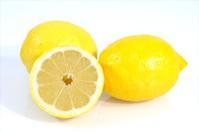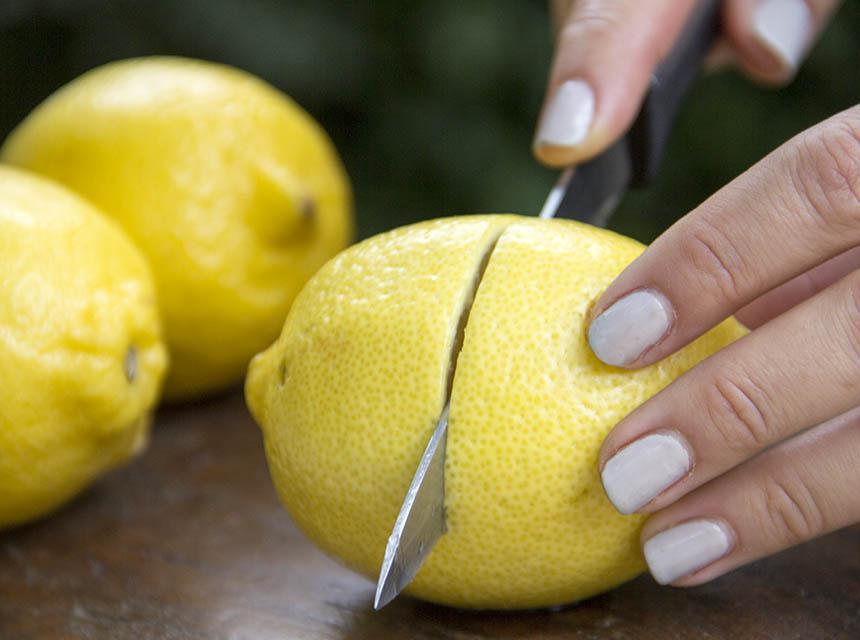The first image is the image on the left, the second image is the image on the right. Examine the images to the left and right. Is the description "In one image, some lemons are cut, in the other, none of the lemons are cut." accurate? Answer yes or no. No. 